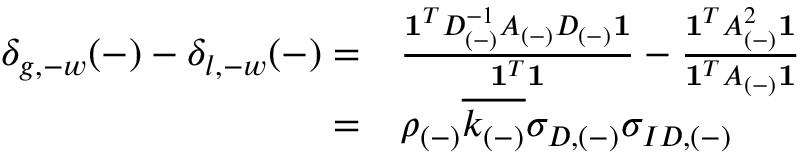<formula> <loc_0><loc_0><loc_500><loc_500>\begin{array} { r l } { \delta _ { g , - w } ( - ) - \delta _ { l , - w } ( - ) = } & { \frac { 1 ^ { T } D _ { ( - ) } ^ { - 1 } A _ { ( - ) } D _ { ( - ) } 1 } { 1 ^ { T } 1 } - \frac { 1 ^ { T } A _ { ( - ) } ^ { 2 } 1 } { 1 ^ { T } A _ { ( - ) } 1 } } \\ { = } & { \rho _ { ( - ) } \overline { { k _ { ( - ) } } } \sigma _ { D , ( - ) } \sigma _ { I D , ( - ) } \, } \end{array}</formula> 